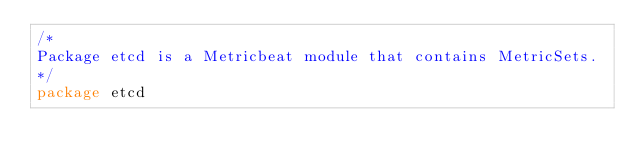Convert code to text. <code><loc_0><loc_0><loc_500><loc_500><_Go_>/*
Package etcd is a Metricbeat module that contains MetricSets.
*/
package etcd
</code> 